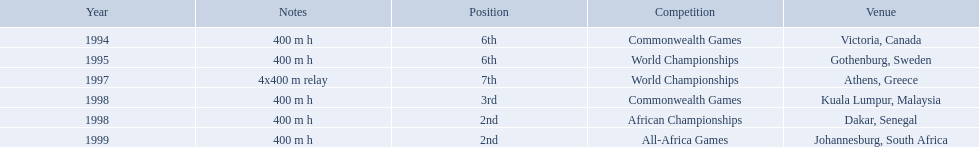What years did ken harder compete in? 1994, 1995, 1997, 1998, 1998, 1999. For the 1997 relay, what distance was ran? 4x400 m relay. 